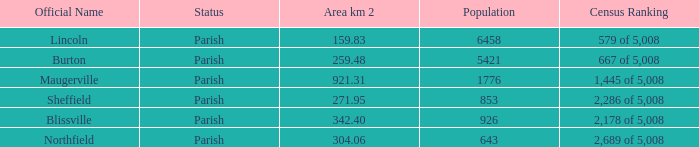What are the census ranking(s) of maugerville? 1,445 of 5,008. 